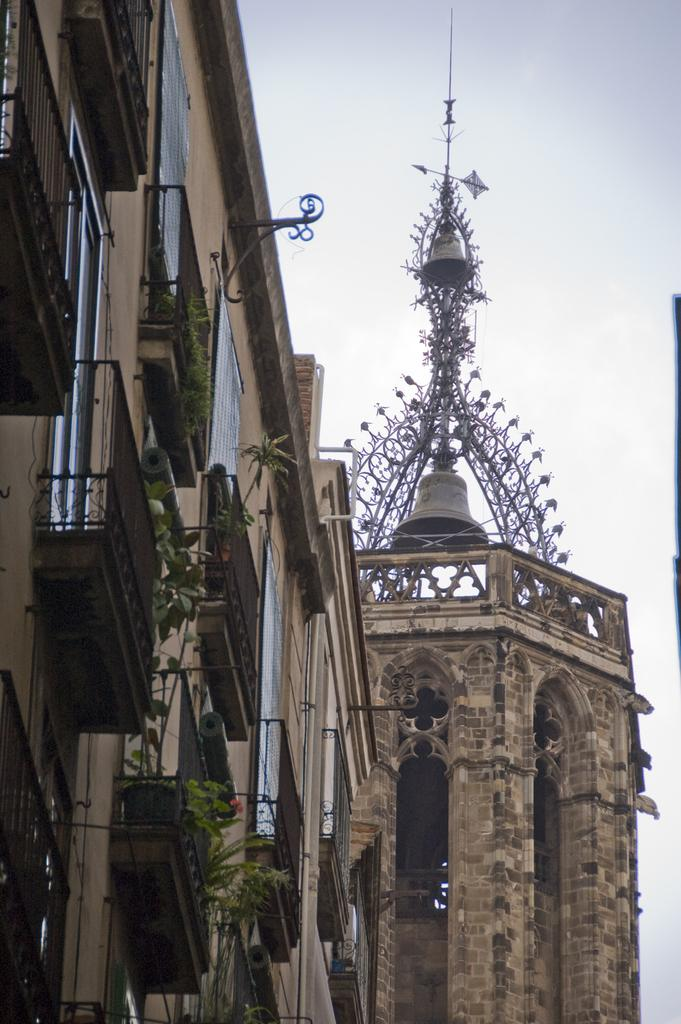What type of structures can be seen in the image? There are buildings in the image. What other elements are present in the image besides the buildings? There are plants in the image, including a red flower. What can be seen in the background of the image? The sky is visible in the background of the image. How does the sister interact with the icicle in the image? There is no sister or icicle present in the image. 